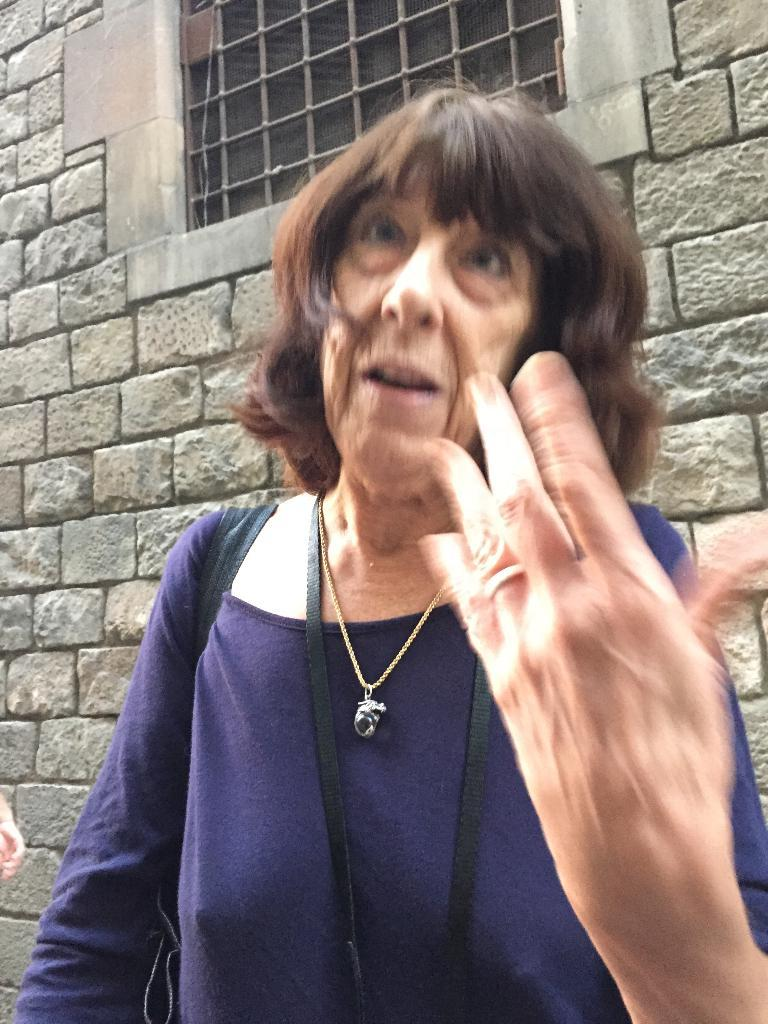Who is the main subject in the image? There is a lady in the image. What is the lady carrying in the image? The lady is carrying a black bag. What can be seen in the background of the image? There is a wall in the background of the image. Can you describe the wall in the image? The wall has a mesh window. What type of teeth can be seen in the image? There are no teeth visible in the image. 